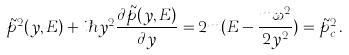<formula> <loc_0><loc_0><loc_500><loc_500>\tilde { p } ^ { 2 } ( y , E ) + i \hbar { y } ^ { 2 } \frac { \partial \tilde { p } ( y , E ) } { \partial y } = 2 m ( E - \frac { m \omega ^ { 2 } } { 2 y ^ { 2 } } ) = \tilde { p } ^ { 2 } _ { c } \, .</formula> 